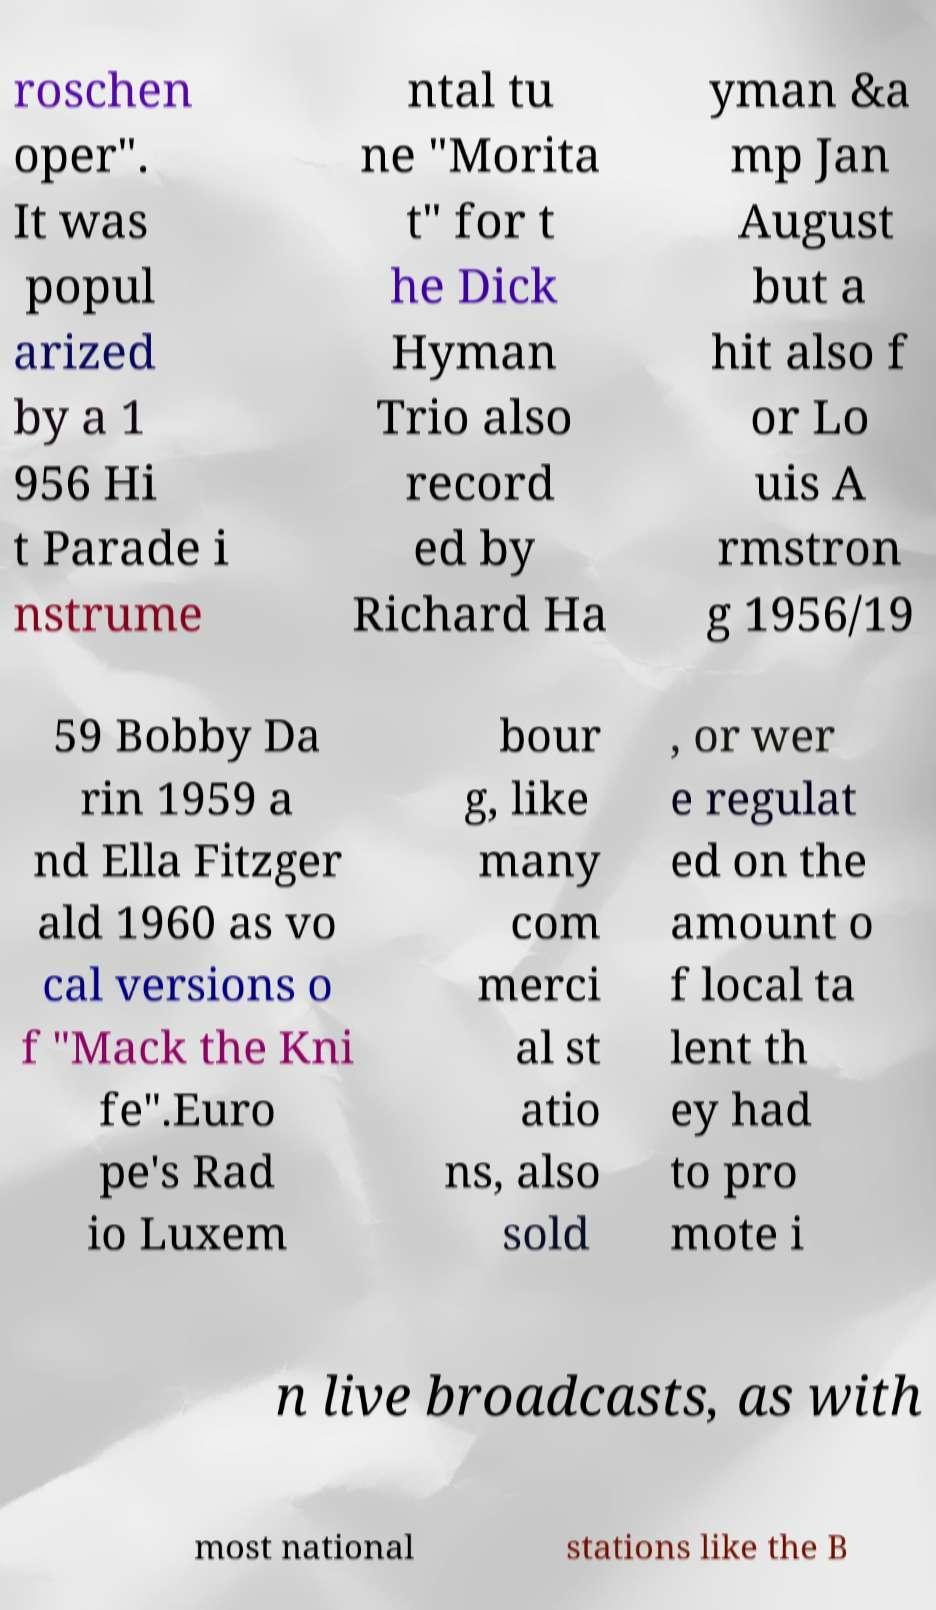What messages or text are displayed in this image? I need them in a readable, typed format. roschen oper". It was popul arized by a 1 956 Hi t Parade i nstrume ntal tu ne "Morita t" for t he Dick Hyman Trio also record ed by Richard Ha yman &a mp Jan August but a hit also f or Lo uis A rmstron g 1956/19 59 Bobby Da rin 1959 a nd Ella Fitzger ald 1960 as vo cal versions o f "Mack the Kni fe".Euro pe's Rad io Luxem bour g, like many com merci al st atio ns, also sold , or wer e regulat ed on the amount o f local ta lent th ey had to pro mote i n live broadcasts, as with most national stations like the B 